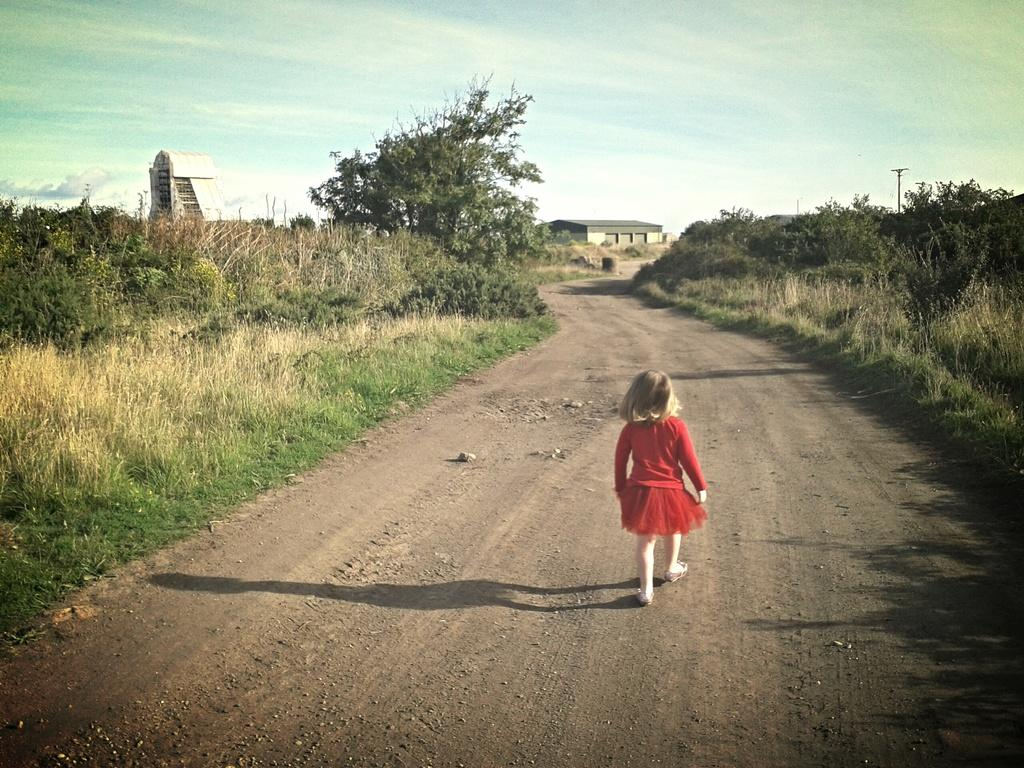What is the main feature in the center of the image? There is a walkway in the center of the image. What is the girl in the image doing? A girl is walking on the walkway. What is the girl wearing? The girl is wearing a red dress. What can be seen in the background of the image? There is grass, trees, sheds, a pole, and the sky visible in the background of the image. What type of winter boots is the girl wearing in the image? The girl is not wearing winter boots in the image; she is wearing a red dress. Can you tell me how many grandmothers are present in the image? There are no grandmothers present in the image; it features a girl walking on a walkway. 